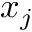Convert formula to latex. <formula><loc_0><loc_0><loc_500><loc_500>x _ { j }</formula> 